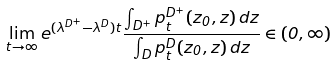<formula> <loc_0><loc_0><loc_500><loc_500>\lim _ { t \to \infty } e ^ { ( \lambda ^ { D ^ { + } } - \lambda ^ { D } ) t } \frac { \int _ { D ^ { + } } p _ { t } ^ { D ^ { + } } ( z _ { 0 } , z ) \, d z } { \int _ { D } p _ { t } ^ { D } ( z _ { 0 } , z ) \, d z } \in ( 0 , \infty )</formula> 